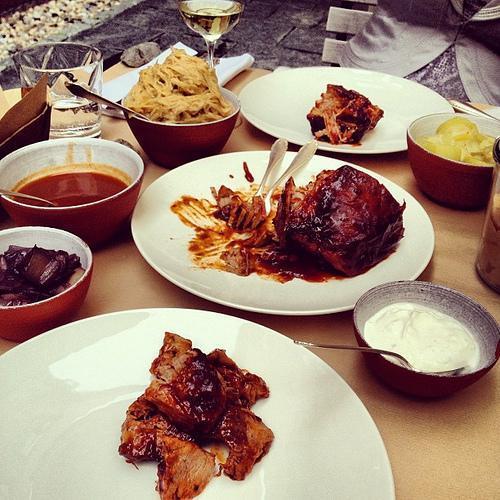How many plates are on the table?
Give a very brief answer. 3. How many utensils are on the table?
Give a very brief answer. 5. How many white plates are visible?
Give a very brief answer. 3. How many red bowls are visible?
Give a very brief answer. 5. How many wine glasses are visible?
Give a very brief answer. 1. How many bowls have a red sauce in them?
Give a very brief answer. 1. How many white dishes have meat on them?
Give a very brief answer. 3. How many red bowls have a white condiment in them?
Give a very brief answer. 1. How many napkins are on the table?
Give a very brief answer. 1. 